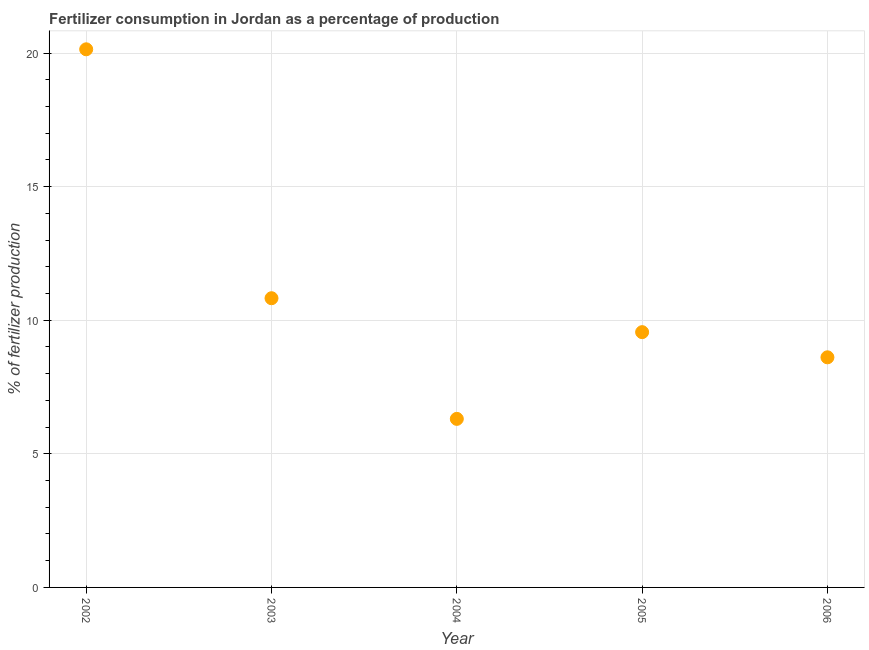What is the amount of fertilizer consumption in 2003?
Give a very brief answer. 10.83. Across all years, what is the maximum amount of fertilizer consumption?
Offer a terse response. 20.14. Across all years, what is the minimum amount of fertilizer consumption?
Offer a very short reply. 6.31. In which year was the amount of fertilizer consumption minimum?
Provide a short and direct response. 2004. What is the sum of the amount of fertilizer consumption?
Your answer should be compact. 55.45. What is the difference between the amount of fertilizer consumption in 2002 and 2004?
Make the answer very short. 13.83. What is the average amount of fertilizer consumption per year?
Your response must be concise. 11.09. What is the median amount of fertilizer consumption?
Ensure brevity in your answer.  9.56. In how many years, is the amount of fertilizer consumption greater than 3 %?
Offer a terse response. 5. What is the ratio of the amount of fertilizer consumption in 2004 to that in 2006?
Offer a very short reply. 0.73. Is the amount of fertilizer consumption in 2004 less than that in 2005?
Your answer should be compact. Yes. What is the difference between the highest and the second highest amount of fertilizer consumption?
Ensure brevity in your answer.  9.32. What is the difference between the highest and the lowest amount of fertilizer consumption?
Give a very brief answer. 13.83. Does the amount of fertilizer consumption monotonically increase over the years?
Provide a succinct answer. No. How many years are there in the graph?
Provide a succinct answer. 5. Does the graph contain any zero values?
Provide a short and direct response. No. What is the title of the graph?
Your answer should be very brief. Fertilizer consumption in Jordan as a percentage of production. What is the label or title of the X-axis?
Your response must be concise. Year. What is the label or title of the Y-axis?
Offer a terse response. % of fertilizer production. What is the % of fertilizer production in 2002?
Make the answer very short. 20.14. What is the % of fertilizer production in 2003?
Your response must be concise. 10.83. What is the % of fertilizer production in 2004?
Your answer should be very brief. 6.31. What is the % of fertilizer production in 2005?
Give a very brief answer. 9.56. What is the % of fertilizer production in 2006?
Provide a succinct answer. 8.61. What is the difference between the % of fertilizer production in 2002 and 2003?
Provide a short and direct response. 9.32. What is the difference between the % of fertilizer production in 2002 and 2004?
Your answer should be compact. 13.83. What is the difference between the % of fertilizer production in 2002 and 2005?
Your response must be concise. 10.59. What is the difference between the % of fertilizer production in 2002 and 2006?
Provide a short and direct response. 11.53. What is the difference between the % of fertilizer production in 2003 and 2004?
Provide a succinct answer. 4.52. What is the difference between the % of fertilizer production in 2003 and 2005?
Make the answer very short. 1.27. What is the difference between the % of fertilizer production in 2003 and 2006?
Ensure brevity in your answer.  2.21. What is the difference between the % of fertilizer production in 2004 and 2005?
Your answer should be compact. -3.25. What is the difference between the % of fertilizer production in 2004 and 2006?
Your response must be concise. -2.3. What is the difference between the % of fertilizer production in 2005 and 2006?
Your answer should be very brief. 0.94. What is the ratio of the % of fertilizer production in 2002 to that in 2003?
Offer a very short reply. 1.86. What is the ratio of the % of fertilizer production in 2002 to that in 2004?
Offer a very short reply. 3.19. What is the ratio of the % of fertilizer production in 2002 to that in 2005?
Offer a terse response. 2.11. What is the ratio of the % of fertilizer production in 2002 to that in 2006?
Keep it short and to the point. 2.34. What is the ratio of the % of fertilizer production in 2003 to that in 2004?
Make the answer very short. 1.72. What is the ratio of the % of fertilizer production in 2003 to that in 2005?
Your answer should be compact. 1.13. What is the ratio of the % of fertilizer production in 2003 to that in 2006?
Provide a short and direct response. 1.26. What is the ratio of the % of fertilizer production in 2004 to that in 2005?
Provide a succinct answer. 0.66. What is the ratio of the % of fertilizer production in 2004 to that in 2006?
Keep it short and to the point. 0.73. What is the ratio of the % of fertilizer production in 2005 to that in 2006?
Keep it short and to the point. 1.11. 